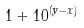<formula> <loc_0><loc_0><loc_500><loc_500>1 + 1 0 ^ { ( y - x ) }</formula> 